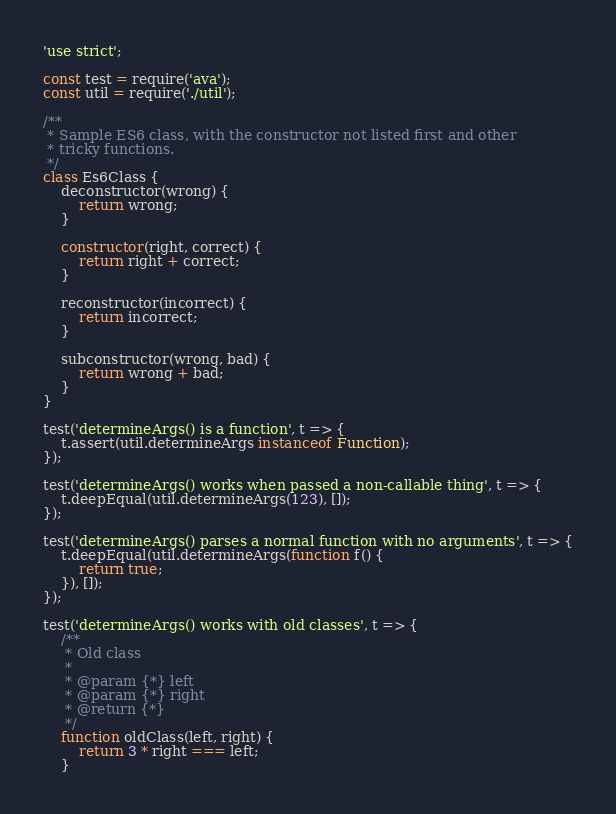Convert code to text. <code><loc_0><loc_0><loc_500><loc_500><_JavaScript_>'use strict';

const test = require('ava');
const util = require('./util');

/**
 * Sample ES6 class, with the constructor not listed first and other
 * tricky functions.
 */
class Es6Class {
    deconstructor(wrong) {
        return wrong;
    }

    constructor(right, correct) {
        return right + correct;
    }

    reconstructor(incorrect) {
        return incorrect;
    }

    subconstructor(wrong, bad) {
        return wrong + bad;
    }
}

test('determineArgs() is a function', t => {
    t.assert(util.determineArgs instanceof Function);
});

test('determineArgs() works when passed a non-callable thing', t => {
    t.deepEqual(util.determineArgs(123), []);
});

test('determineArgs() parses a normal function with no arguments', t => {
    t.deepEqual(util.determineArgs(function f() {
        return true;
    }), []);
});

test('determineArgs() works with old classes', t => {
    /**
     * Old class
     *
     * @param {*} left
     * @param {*} right
     * @return {*}
     */
    function oldClass(left, right) {
        return 3 * right === left;
    }
</code> 